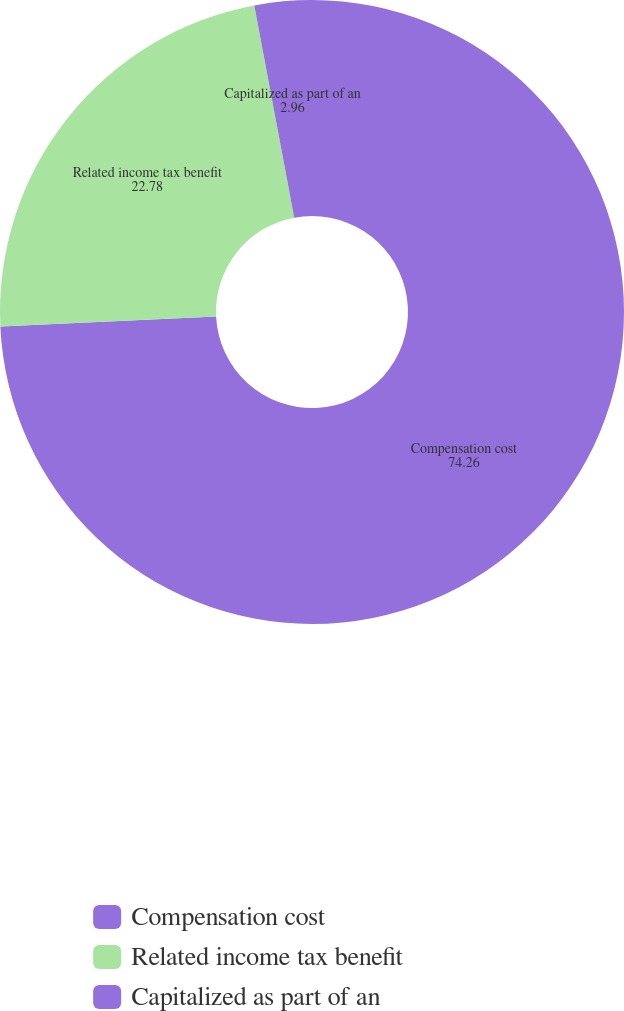Convert chart. <chart><loc_0><loc_0><loc_500><loc_500><pie_chart><fcel>Compensation cost<fcel>Related income tax benefit<fcel>Capitalized as part of an<nl><fcel>74.26%<fcel>22.78%<fcel>2.96%<nl></chart> 